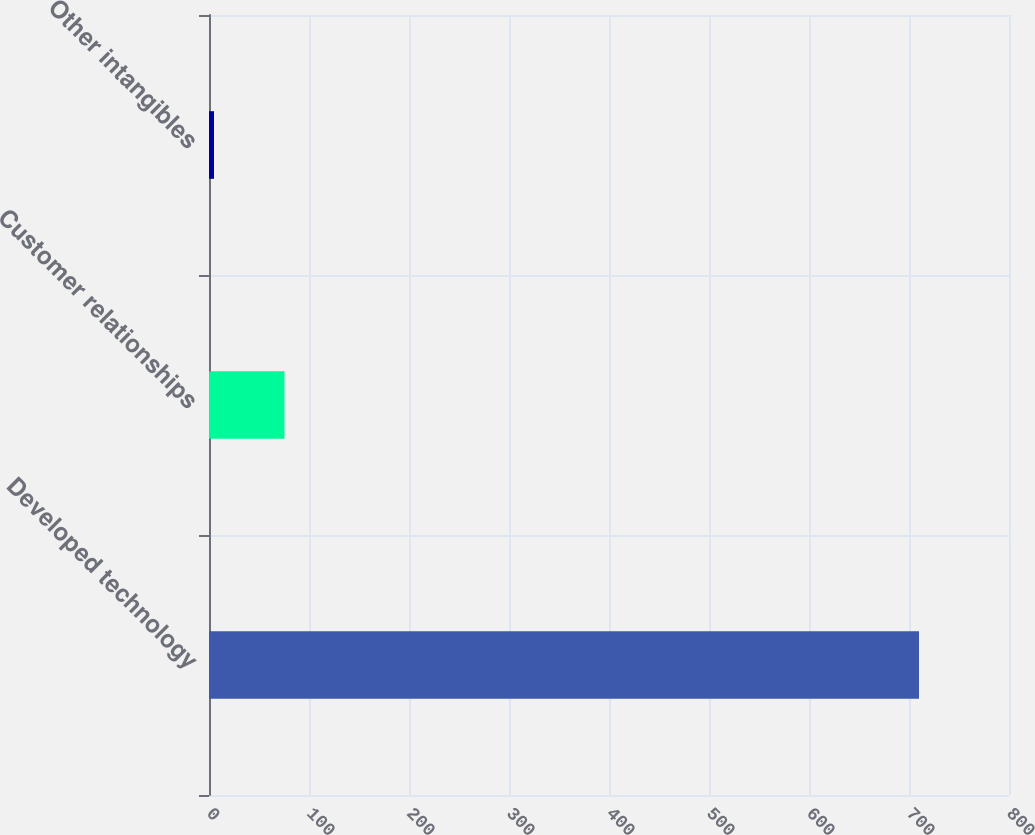<chart> <loc_0><loc_0><loc_500><loc_500><bar_chart><fcel>Developed technology<fcel>Customer relationships<fcel>Other intangibles<nl><fcel>710<fcel>75.5<fcel>5<nl></chart> 